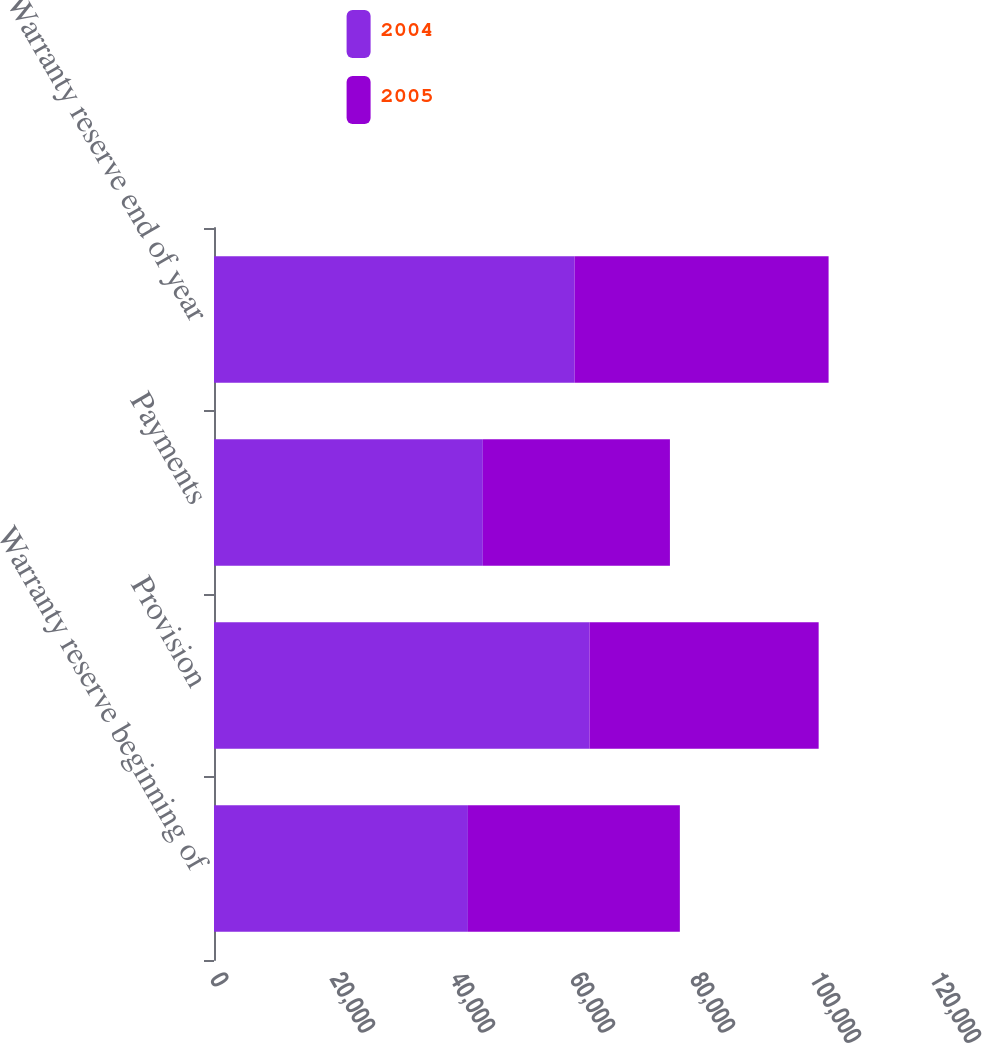<chart> <loc_0><loc_0><loc_500><loc_500><stacked_bar_chart><ecel><fcel>Warranty reserve beginning of<fcel>Provision<fcel>Payments<fcel>Warranty reserve end of year<nl><fcel>2004<fcel>42319<fcel>62598<fcel>44805<fcel>60112<nl><fcel>2005<fcel>35324<fcel>38178<fcel>31183<fcel>42319<nl></chart> 